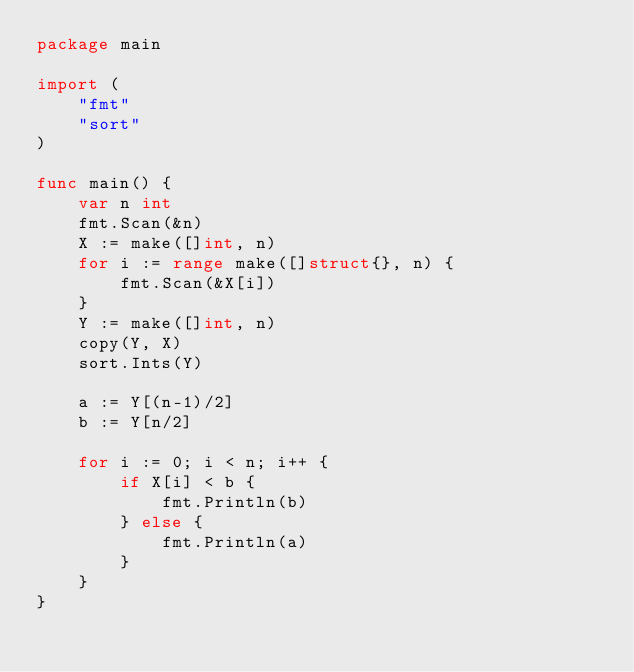<code> <loc_0><loc_0><loc_500><loc_500><_Go_>package main

import (
	"fmt"
	"sort"
)

func main() {
	var n int
	fmt.Scan(&n)
	X := make([]int, n)
	for i := range make([]struct{}, n) {
		fmt.Scan(&X[i])
	}
	Y := make([]int, n)
	copy(Y, X)
	sort.Ints(Y)

	a := Y[(n-1)/2]
	b := Y[n/2]

	for i := 0; i < n; i++ {
		if X[i] < b {
			fmt.Println(b)
		} else {
			fmt.Println(a)
		}
	}
}
</code> 